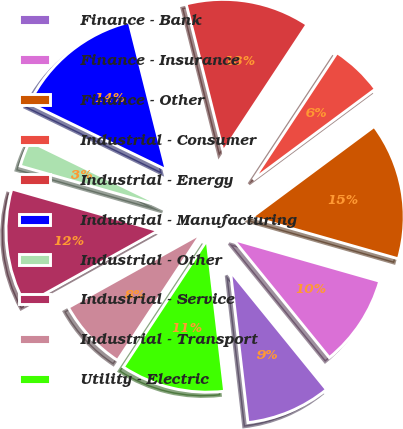Convert chart to OTSL. <chart><loc_0><loc_0><loc_500><loc_500><pie_chart><fcel>Finance - Bank<fcel>Finance - Insurance<fcel>Finance - Other<fcel>Industrial - Consumer<fcel>Industrial - Energy<fcel>Industrial - Manufacturing<fcel>Industrial - Other<fcel>Industrial - Service<fcel>Industrial - Transport<fcel>Utility - Electric<nl><fcel>9.03%<fcel>9.72%<fcel>14.58%<fcel>5.56%<fcel>13.19%<fcel>13.89%<fcel>2.78%<fcel>12.5%<fcel>7.64%<fcel>11.11%<nl></chart> 